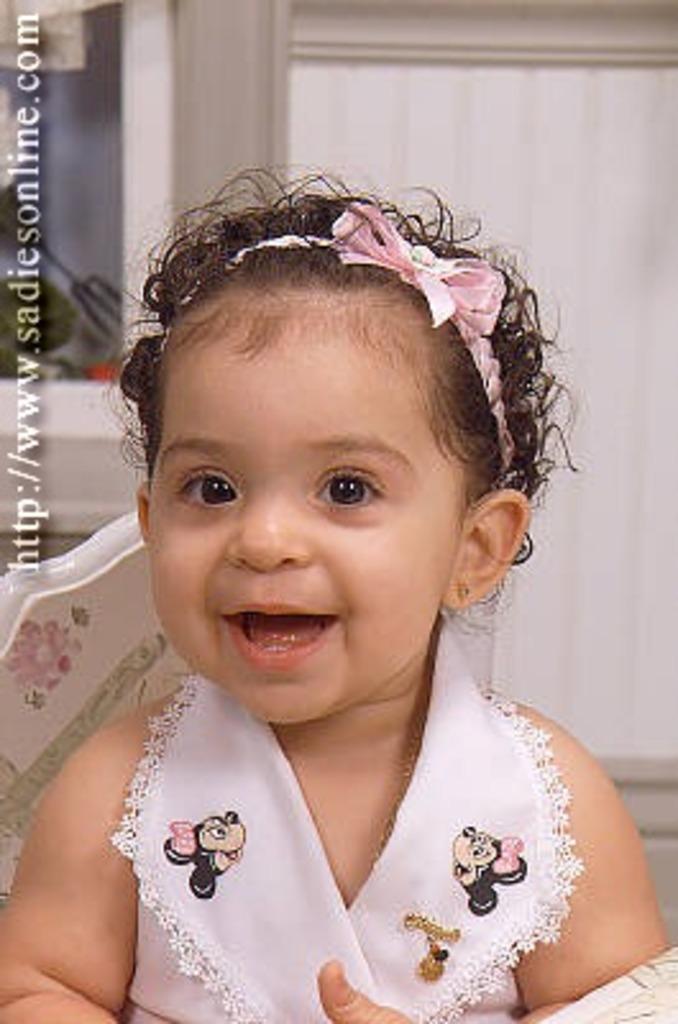Can you describe this image briefly? In the picture I can see a girl and there is a pretty smile on her face. 